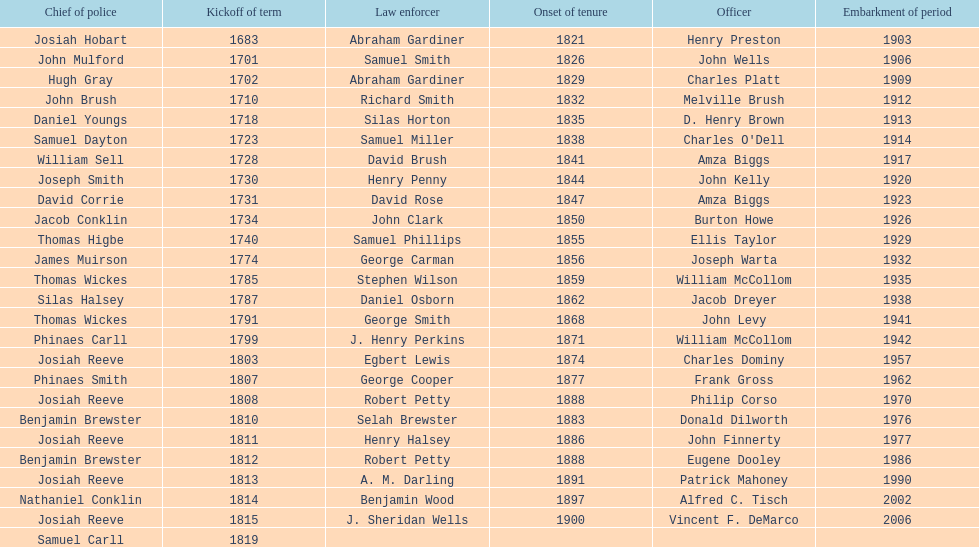Write the full table. {'header': ['Chief of police', 'Kickoff of term', 'Law enforcer', 'Onset of tenure', 'Officer', 'Embarkment of period'], 'rows': [['Josiah Hobart', '1683', 'Abraham Gardiner', '1821', 'Henry Preston', '1903'], ['John Mulford', '1701', 'Samuel Smith', '1826', 'John Wells', '1906'], ['Hugh Gray', '1702', 'Abraham Gardiner', '1829', 'Charles Platt', '1909'], ['John Brush', '1710', 'Richard Smith', '1832', 'Melville Brush', '1912'], ['Daniel Youngs', '1718', 'Silas Horton', '1835', 'D. Henry Brown', '1913'], ['Samuel Dayton', '1723', 'Samuel Miller', '1838', "Charles O'Dell", '1914'], ['William Sell', '1728', 'David Brush', '1841', 'Amza Biggs', '1917'], ['Joseph Smith', '1730', 'Henry Penny', '1844', 'John Kelly', '1920'], ['David Corrie', '1731', 'David Rose', '1847', 'Amza Biggs', '1923'], ['Jacob Conklin', '1734', 'John Clark', '1850', 'Burton Howe', '1926'], ['Thomas Higbe', '1740', 'Samuel Phillips', '1855', 'Ellis Taylor', '1929'], ['James Muirson', '1774', 'George Carman', '1856', 'Joseph Warta', '1932'], ['Thomas Wickes', '1785', 'Stephen Wilson', '1859', 'William McCollom', '1935'], ['Silas Halsey', '1787', 'Daniel Osborn', '1862', 'Jacob Dreyer', '1938'], ['Thomas Wickes', '1791', 'George Smith', '1868', 'John Levy', '1941'], ['Phinaes Carll', '1799', 'J. Henry Perkins', '1871', 'William McCollom', '1942'], ['Josiah Reeve', '1803', 'Egbert Lewis', '1874', 'Charles Dominy', '1957'], ['Phinaes Smith', '1807', 'George Cooper', '1877', 'Frank Gross', '1962'], ['Josiah Reeve', '1808', 'Robert Petty', '1888', 'Philip Corso', '1970'], ['Benjamin Brewster', '1810', 'Selah Brewster', '1883', 'Donald Dilworth', '1976'], ['Josiah Reeve', '1811', 'Henry Halsey', '1886', 'John Finnerty', '1977'], ['Benjamin Brewster', '1812', 'Robert Petty', '1888', 'Eugene Dooley', '1986'], ['Josiah Reeve', '1813', 'A. M. Darling', '1891', 'Patrick Mahoney', '1990'], ['Nathaniel Conklin', '1814', 'Benjamin Wood', '1897', 'Alfred C. Tisch', '2002'], ['Josiah Reeve', '1815', 'J. Sheridan Wells', '1900', 'Vincent F. DeMarco', '2006'], ['Samuel Carll', '1819', '', '', '', '']]} When did the first sheriff's term start? 1683. 